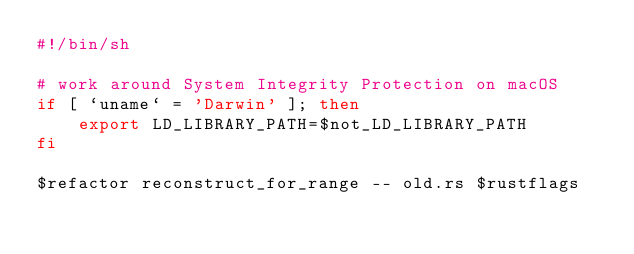Convert code to text. <code><loc_0><loc_0><loc_500><loc_500><_Bash_>#!/bin/sh

# work around System Integrity Protection on macOS
if [ `uname` = 'Darwin' ]; then
    export LD_LIBRARY_PATH=$not_LD_LIBRARY_PATH
fi

$refactor reconstruct_for_range -- old.rs $rustflags
</code> 